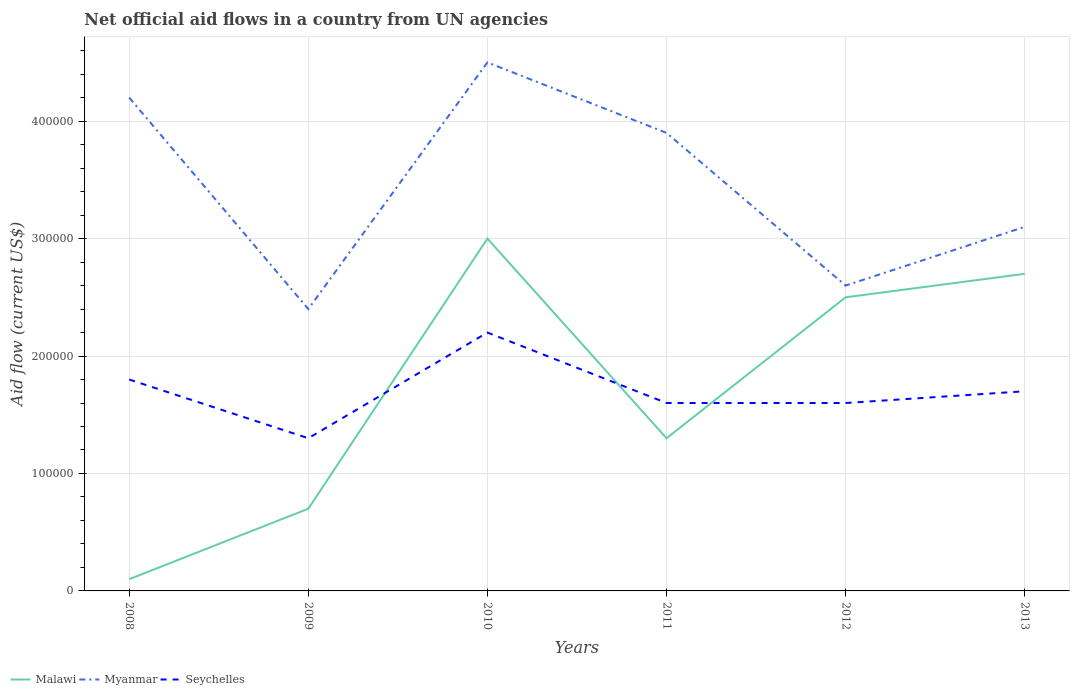In which year was the net official aid flow in Seychelles maximum?
Give a very brief answer. 2009. What is the total net official aid flow in Seychelles in the graph?
Provide a short and direct response. -9.00e+04. What is the difference between the highest and the second highest net official aid flow in Malawi?
Provide a short and direct response. 2.90e+05. What is the difference between the highest and the lowest net official aid flow in Malawi?
Keep it short and to the point. 3. How many lines are there?
Your response must be concise. 3. How many years are there in the graph?
Keep it short and to the point. 6. What is the difference between two consecutive major ticks on the Y-axis?
Make the answer very short. 1.00e+05. Where does the legend appear in the graph?
Keep it short and to the point. Bottom left. How many legend labels are there?
Provide a short and direct response. 3. What is the title of the graph?
Your response must be concise. Net official aid flows in a country from UN agencies. What is the label or title of the X-axis?
Provide a succinct answer. Years. What is the Aid flow (current US$) of Malawi in 2008?
Your answer should be very brief. 10000. What is the Aid flow (current US$) in Myanmar in 2009?
Your answer should be compact. 2.40e+05. What is the Aid flow (current US$) in Seychelles in 2009?
Your response must be concise. 1.30e+05. What is the Aid flow (current US$) of Malawi in 2010?
Give a very brief answer. 3.00e+05. What is the Aid flow (current US$) of Myanmar in 2010?
Give a very brief answer. 4.50e+05. What is the Aid flow (current US$) in Seychelles in 2010?
Ensure brevity in your answer.  2.20e+05. What is the Aid flow (current US$) of Myanmar in 2011?
Your answer should be very brief. 3.90e+05. What is the Aid flow (current US$) in Seychelles in 2011?
Offer a terse response. 1.60e+05. What is the Aid flow (current US$) of Malawi in 2012?
Provide a short and direct response. 2.50e+05. What is the Aid flow (current US$) of Myanmar in 2012?
Your answer should be very brief. 2.60e+05. What is the Aid flow (current US$) of Myanmar in 2013?
Your response must be concise. 3.10e+05. What is the Aid flow (current US$) in Seychelles in 2013?
Offer a very short reply. 1.70e+05. Across all years, what is the maximum Aid flow (current US$) of Myanmar?
Your answer should be compact. 4.50e+05. Across all years, what is the minimum Aid flow (current US$) in Malawi?
Provide a succinct answer. 10000. Across all years, what is the minimum Aid flow (current US$) in Myanmar?
Provide a succinct answer. 2.40e+05. What is the total Aid flow (current US$) of Malawi in the graph?
Offer a very short reply. 1.03e+06. What is the total Aid flow (current US$) of Myanmar in the graph?
Your answer should be compact. 2.07e+06. What is the total Aid flow (current US$) in Seychelles in the graph?
Make the answer very short. 1.02e+06. What is the difference between the Aid flow (current US$) of Malawi in 2008 and that in 2009?
Provide a short and direct response. -6.00e+04. What is the difference between the Aid flow (current US$) of Seychelles in 2008 and that in 2009?
Your answer should be very brief. 5.00e+04. What is the difference between the Aid flow (current US$) of Malawi in 2008 and that in 2010?
Keep it short and to the point. -2.90e+05. What is the difference between the Aid flow (current US$) of Myanmar in 2008 and that in 2010?
Your answer should be compact. -3.00e+04. What is the difference between the Aid flow (current US$) of Seychelles in 2008 and that in 2010?
Ensure brevity in your answer.  -4.00e+04. What is the difference between the Aid flow (current US$) of Malawi in 2008 and that in 2011?
Provide a succinct answer. -1.20e+05. What is the difference between the Aid flow (current US$) in Myanmar in 2008 and that in 2011?
Give a very brief answer. 3.00e+04. What is the difference between the Aid flow (current US$) of Seychelles in 2008 and that in 2011?
Offer a very short reply. 2.00e+04. What is the difference between the Aid flow (current US$) in Myanmar in 2008 and that in 2012?
Give a very brief answer. 1.60e+05. What is the difference between the Aid flow (current US$) in Seychelles in 2008 and that in 2012?
Your response must be concise. 2.00e+04. What is the difference between the Aid flow (current US$) of Malawi in 2008 and that in 2013?
Offer a terse response. -2.60e+05. What is the difference between the Aid flow (current US$) of Myanmar in 2008 and that in 2013?
Provide a succinct answer. 1.10e+05. What is the difference between the Aid flow (current US$) in Myanmar in 2009 and that in 2010?
Keep it short and to the point. -2.10e+05. What is the difference between the Aid flow (current US$) of Seychelles in 2009 and that in 2010?
Provide a succinct answer. -9.00e+04. What is the difference between the Aid flow (current US$) in Malawi in 2009 and that in 2011?
Your answer should be compact. -6.00e+04. What is the difference between the Aid flow (current US$) of Myanmar in 2009 and that in 2011?
Keep it short and to the point. -1.50e+05. What is the difference between the Aid flow (current US$) in Seychelles in 2009 and that in 2011?
Make the answer very short. -3.00e+04. What is the difference between the Aid flow (current US$) of Myanmar in 2009 and that in 2013?
Offer a terse response. -7.00e+04. What is the difference between the Aid flow (current US$) in Seychelles in 2009 and that in 2013?
Make the answer very short. -4.00e+04. What is the difference between the Aid flow (current US$) in Malawi in 2010 and that in 2011?
Keep it short and to the point. 1.70e+05. What is the difference between the Aid flow (current US$) of Myanmar in 2010 and that in 2011?
Provide a short and direct response. 6.00e+04. What is the difference between the Aid flow (current US$) in Seychelles in 2010 and that in 2011?
Your answer should be compact. 6.00e+04. What is the difference between the Aid flow (current US$) in Malawi in 2010 and that in 2012?
Offer a terse response. 5.00e+04. What is the difference between the Aid flow (current US$) in Myanmar in 2010 and that in 2012?
Ensure brevity in your answer.  1.90e+05. What is the difference between the Aid flow (current US$) in Seychelles in 2010 and that in 2012?
Give a very brief answer. 6.00e+04. What is the difference between the Aid flow (current US$) in Seychelles in 2011 and that in 2013?
Ensure brevity in your answer.  -10000. What is the difference between the Aid flow (current US$) of Seychelles in 2012 and that in 2013?
Ensure brevity in your answer.  -10000. What is the difference between the Aid flow (current US$) in Malawi in 2008 and the Aid flow (current US$) in Seychelles in 2009?
Your answer should be compact. -1.20e+05. What is the difference between the Aid flow (current US$) of Myanmar in 2008 and the Aid flow (current US$) of Seychelles in 2009?
Keep it short and to the point. 2.90e+05. What is the difference between the Aid flow (current US$) in Malawi in 2008 and the Aid flow (current US$) in Myanmar in 2010?
Make the answer very short. -4.40e+05. What is the difference between the Aid flow (current US$) of Malawi in 2008 and the Aid flow (current US$) of Seychelles in 2010?
Provide a short and direct response. -2.10e+05. What is the difference between the Aid flow (current US$) of Malawi in 2008 and the Aid flow (current US$) of Myanmar in 2011?
Make the answer very short. -3.80e+05. What is the difference between the Aid flow (current US$) of Myanmar in 2008 and the Aid flow (current US$) of Seychelles in 2011?
Your response must be concise. 2.60e+05. What is the difference between the Aid flow (current US$) of Malawi in 2008 and the Aid flow (current US$) of Myanmar in 2012?
Keep it short and to the point. -2.50e+05. What is the difference between the Aid flow (current US$) of Malawi in 2008 and the Aid flow (current US$) of Myanmar in 2013?
Give a very brief answer. -3.00e+05. What is the difference between the Aid flow (current US$) of Malawi in 2008 and the Aid flow (current US$) of Seychelles in 2013?
Your answer should be very brief. -1.60e+05. What is the difference between the Aid flow (current US$) in Malawi in 2009 and the Aid flow (current US$) in Myanmar in 2010?
Your answer should be very brief. -3.80e+05. What is the difference between the Aid flow (current US$) of Myanmar in 2009 and the Aid flow (current US$) of Seychelles in 2010?
Ensure brevity in your answer.  2.00e+04. What is the difference between the Aid flow (current US$) of Malawi in 2009 and the Aid flow (current US$) of Myanmar in 2011?
Make the answer very short. -3.20e+05. What is the difference between the Aid flow (current US$) in Malawi in 2009 and the Aid flow (current US$) in Myanmar in 2012?
Give a very brief answer. -1.90e+05. What is the difference between the Aid flow (current US$) of Malawi in 2009 and the Aid flow (current US$) of Seychelles in 2012?
Offer a very short reply. -9.00e+04. What is the difference between the Aid flow (current US$) of Malawi in 2009 and the Aid flow (current US$) of Myanmar in 2013?
Your answer should be compact. -2.40e+05. What is the difference between the Aid flow (current US$) in Malawi in 2009 and the Aid flow (current US$) in Seychelles in 2013?
Provide a short and direct response. -1.00e+05. What is the difference between the Aid flow (current US$) in Myanmar in 2009 and the Aid flow (current US$) in Seychelles in 2013?
Keep it short and to the point. 7.00e+04. What is the difference between the Aid flow (current US$) of Malawi in 2010 and the Aid flow (current US$) of Myanmar in 2011?
Make the answer very short. -9.00e+04. What is the difference between the Aid flow (current US$) of Myanmar in 2010 and the Aid flow (current US$) of Seychelles in 2011?
Keep it short and to the point. 2.90e+05. What is the difference between the Aid flow (current US$) of Malawi in 2010 and the Aid flow (current US$) of Seychelles in 2012?
Provide a succinct answer. 1.40e+05. What is the difference between the Aid flow (current US$) in Myanmar in 2010 and the Aid flow (current US$) in Seychelles in 2012?
Give a very brief answer. 2.90e+05. What is the difference between the Aid flow (current US$) in Malawi in 2010 and the Aid flow (current US$) in Myanmar in 2013?
Offer a very short reply. -10000. What is the difference between the Aid flow (current US$) of Malawi in 2010 and the Aid flow (current US$) of Seychelles in 2013?
Your answer should be very brief. 1.30e+05. What is the difference between the Aid flow (current US$) in Myanmar in 2010 and the Aid flow (current US$) in Seychelles in 2013?
Provide a succinct answer. 2.80e+05. What is the difference between the Aid flow (current US$) of Malawi in 2011 and the Aid flow (current US$) of Seychelles in 2012?
Keep it short and to the point. -3.00e+04. What is the difference between the Aid flow (current US$) in Malawi in 2011 and the Aid flow (current US$) in Seychelles in 2013?
Give a very brief answer. -4.00e+04. What is the average Aid flow (current US$) of Malawi per year?
Offer a terse response. 1.72e+05. What is the average Aid flow (current US$) in Myanmar per year?
Your response must be concise. 3.45e+05. What is the average Aid flow (current US$) of Seychelles per year?
Your answer should be very brief. 1.70e+05. In the year 2008, what is the difference between the Aid flow (current US$) in Malawi and Aid flow (current US$) in Myanmar?
Ensure brevity in your answer.  -4.10e+05. In the year 2008, what is the difference between the Aid flow (current US$) of Malawi and Aid flow (current US$) of Seychelles?
Keep it short and to the point. -1.70e+05. In the year 2008, what is the difference between the Aid flow (current US$) of Myanmar and Aid flow (current US$) of Seychelles?
Your answer should be compact. 2.40e+05. In the year 2009, what is the difference between the Aid flow (current US$) in Malawi and Aid flow (current US$) in Myanmar?
Offer a very short reply. -1.70e+05. In the year 2009, what is the difference between the Aid flow (current US$) in Malawi and Aid flow (current US$) in Seychelles?
Ensure brevity in your answer.  -6.00e+04. In the year 2011, what is the difference between the Aid flow (current US$) in Malawi and Aid flow (current US$) in Myanmar?
Your response must be concise. -2.60e+05. In the year 2011, what is the difference between the Aid flow (current US$) in Malawi and Aid flow (current US$) in Seychelles?
Offer a very short reply. -3.00e+04. In the year 2012, what is the difference between the Aid flow (current US$) in Malawi and Aid flow (current US$) in Myanmar?
Offer a very short reply. -10000. In the year 2012, what is the difference between the Aid flow (current US$) of Malawi and Aid flow (current US$) of Seychelles?
Your answer should be compact. 9.00e+04. In the year 2012, what is the difference between the Aid flow (current US$) of Myanmar and Aid flow (current US$) of Seychelles?
Your answer should be very brief. 1.00e+05. In the year 2013, what is the difference between the Aid flow (current US$) in Malawi and Aid flow (current US$) in Myanmar?
Keep it short and to the point. -4.00e+04. In the year 2013, what is the difference between the Aid flow (current US$) in Malawi and Aid flow (current US$) in Seychelles?
Offer a terse response. 1.00e+05. What is the ratio of the Aid flow (current US$) of Malawi in 2008 to that in 2009?
Ensure brevity in your answer.  0.14. What is the ratio of the Aid flow (current US$) in Seychelles in 2008 to that in 2009?
Your answer should be very brief. 1.38. What is the ratio of the Aid flow (current US$) in Malawi in 2008 to that in 2010?
Give a very brief answer. 0.03. What is the ratio of the Aid flow (current US$) in Myanmar in 2008 to that in 2010?
Your answer should be very brief. 0.93. What is the ratio of the Aid flow (current US$) in Seychelles in 2008 to that in 2010?
Keep it short and to the point. 0.82. What is the ratio of the Aid flow (current US$) in Malawi in 2008 to that in 2011?
Offer a very short reply. 0.08. What is the ratio of the Aid flow (current US$) in Malawi in 2008 to that in 2012?
Provide a succinct answer. 0.04. What is the ratio of the Aid flow (current US$) of Myanmar in 2008 to that in 2012?
Make the answer very short. 1.62. What is the ratio of the Aid flow (current US$) of Seychelles in 2008 to that in 2012?
Your response must be concise. 1.12. What is the ratio of the Aid flow (current US$) of Malawi in 2008 to that in 2013?
Provide a short and direct response. 0.04. What is the ratio of the Aid flow (current US$) in Myanmar in 2008 to that in 2013?
Offer a very short reply. 1.35. What is the ratio of the Aid flow (current US$) in Seychelles in 2008 to that in 2013?
Give a very brief answer. 1.06. What is the ratio of the Aid flow (current US$) of Malawi in 2009 to that in 2010?
Ensure brevity in your answer.  0.23. What is the ratio of the Aid flow (current US$) of Myanmar in 2009 to that in 2010?
Offer a terse response. 0.53. What is the ratio of the Aid flow (current US$) of Seychelles in 2009 to that in 2010?
Provide a short and direct response. 0.59. What is the ratio of the Aid flow (current US$) in Malawi in 2009 to that in 2011?
Provide a short and direct response. 0.54. What is the ratio of the Aid flow (current US$) in Myanmar in 2009 to that in 2011?
Give a very brief answer. 0.62. What is the ratio of the Aid flow (current US$) in Seychelles in 2009 to that in 2011?
Offer a terse response. 0.81. What is the ratio of the Aid flow (current US$) of Malawi in 2009 to that in 2012?
Ensure brevity in your answer.  0.28. What is the ratio of the Aid flow (current US$) of Myanmar in 2009 to that in 2012?
Keep it short and to the point. 0.92. What is the ratio of the Aid flow (current US$) in Seychelles in 2009 to that in 2012?
Offer a very short reply. 0.81. What is the ratio of the Aid flow (current US$) in Malawi in 2009 to that in 2013?
Provide a short and direct response. 0.26. What is the ratio of the Aid flow (current US$) in Myanmar in 2009 to that in 2013?
Make the answer very short. 0.77. What is the ratio of the Aid flow (current US$) in Seychelles in 2009 to that in 2013?
Provide a short and direct response. 0.76. What is the ratio of the Aid flow (current US$) of Malawi in 2010 to that in 2011?
Give a very brief answer. 2.31. What is the ratio of the Aid flow (current US$) in Myanmar in 2010 to that in 2011?
Your answer should be compact. 1.15. What is the ratio of the Aid flow (current US$) in Seychelles in 2010 to that in 2011?
Provide a short and direct response. 1.38. What is the ratio of the Aid flow (current US$) of Malawi in 2010 to that in 2012?
Keep it short and to the point. 1.2. What is the ratio of the Aid flow (current US$) of Myanmar in 2010 to that in 2012?
Give a very brief answer. 1.73. What is the ratio of the Aid flow (current US$) of Seychelles in 2010 to that in 2012?
Your answer should be very brief. 1.38. What is the ratio of the Aid flow (current US$) in Myanmar in 2010 to that in 2013?
Ensure brevity in your answer.  1.45. What is the ratio of the Aid flow (current US$) in Seychelles in 2010 to that in 2013?
Offer a very short reply. 1.29. What is the ratio of the Aid flow (current US$) of Malawi in 2011 to that in 2012?
Provide a short and direct response. 0.52. What is the ratio of the Aid flow (current US$) in Malawi in 2011 to that in 2013?
Provide a short and direct response. 0.48. What is the ratio of the Aid flow (current US$) of Myanmar in 2011 to that in 2013?
Keep it short and to the point. 1.26. What is the ratio of the Aid flow (current US$) in Malawi in 2012 to that in 2013?
Keep it short and to the point. 0.93. What is the ratio of the Aid flow (current US$) in Myanmar in 2012 to that in 2013?
Give a very brief answer. 0.84. What is the ratio of the Aid flow (current US$) of Seychelles in 2012 to that in 2013?
Offer a very short reply. 0.94. What is the difference between the highest and the second highest Aid flow (current US$) in Malawi?
Make the answer very short. 3.00e+04. What is the difference between the highest and the lowest Aid flow (current US$) of Myanmar?
Your answer should be very brief. 2.10e+05. What is the difference between the highest and the lowest Aid flow (current US$) in Seychelles?
Provide a short and direct response. 9.00e+04. 